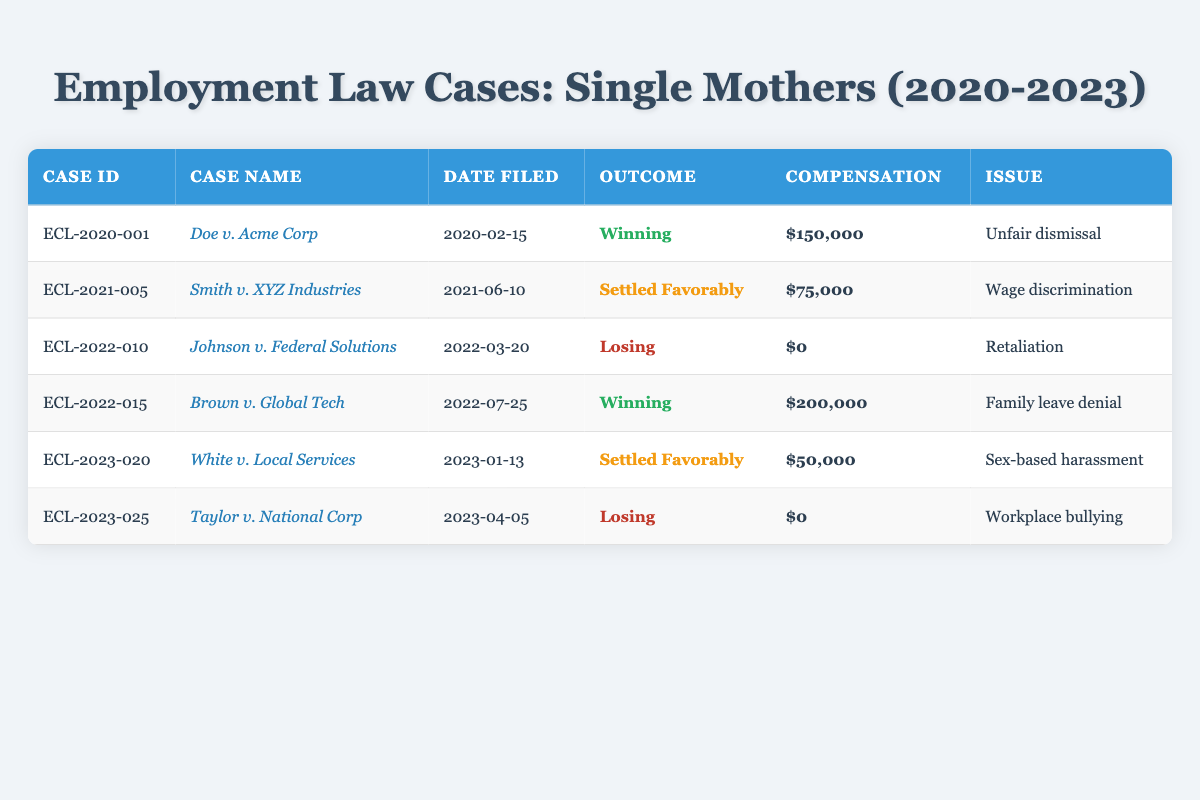What is the total compensation awarded to winning cases? The winning cases are "Doe v. Acme Corp" with $150,000 and "Brown v. Global Tech" with $200,000. Adding these amounts gives $150,000 + $200,000 = $350,000.
Answer: $350,000 How many cases were settled favorably? There are two cases marked as settled favorably: "Smith v. XYZ Industries" and "White v. Local Services."
Answer: 2 What was the outcome of the case filed on 2023-04-05? The case filed on that date is "Taylor v. National Corp," which has an outcome of "Losing."
Answer: Losing Which case resulted in the highest compensation? The case with the highest compensation is "Brown v. Global Tech," awarding $200,000.
Answer: Brown v. Global Tech Did any cases involve wage discrimination? Yes, the case "Smith v. XYZ Industries" involved wage discrimination.
Answer: Yes What is the average compensation awarded in settled cases? The settled cases are "Smith v. XYZ Industries" ($75,000) and "White v. Local Services" ($50,000). The total compensation is $75,000 + $50,000 = $125,000, and there are 2 cases, so the average is $125,000 / 2 = $62,500.
Answer: $62,500 How many cases had a "Losing" outcome? There are two cases with a "Losing" outcome: "Johnson v. Federal Solutions" and "Taylor v. National Corp."
Answer: 2 What was the issue presented in the case that was settled favorably and awarded $50,000? The case settled favorably for $50,000 is "White v. Local Services," and the issue was "Sex-based harassment."
Answer: Sex-based harassment Which case filed in 2021 had a favorable outcome? The case filed in 2021 with a favorable outcome is "Smith v. XYZ Industries," which was settled favorably.
Answer: Smith v. XYZ Industries Which issue resulted in the lowest compensation among winning cases? For winning cases, "Doe v. Acme Corp" awarded $150,000, while "Brown v. Global Tech" awarded $200,000. The lowest compensation among winning cases is $150,000 for unfair dismissal.
Answer: $150,000 